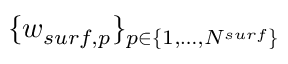<formula> <loc_0><loc_0><loc_500><loc_500>\{ w _ { s u r f , p } \} _ { p \in \{ 1 , \dots , N ^ { s u r f } \} }</formula> 